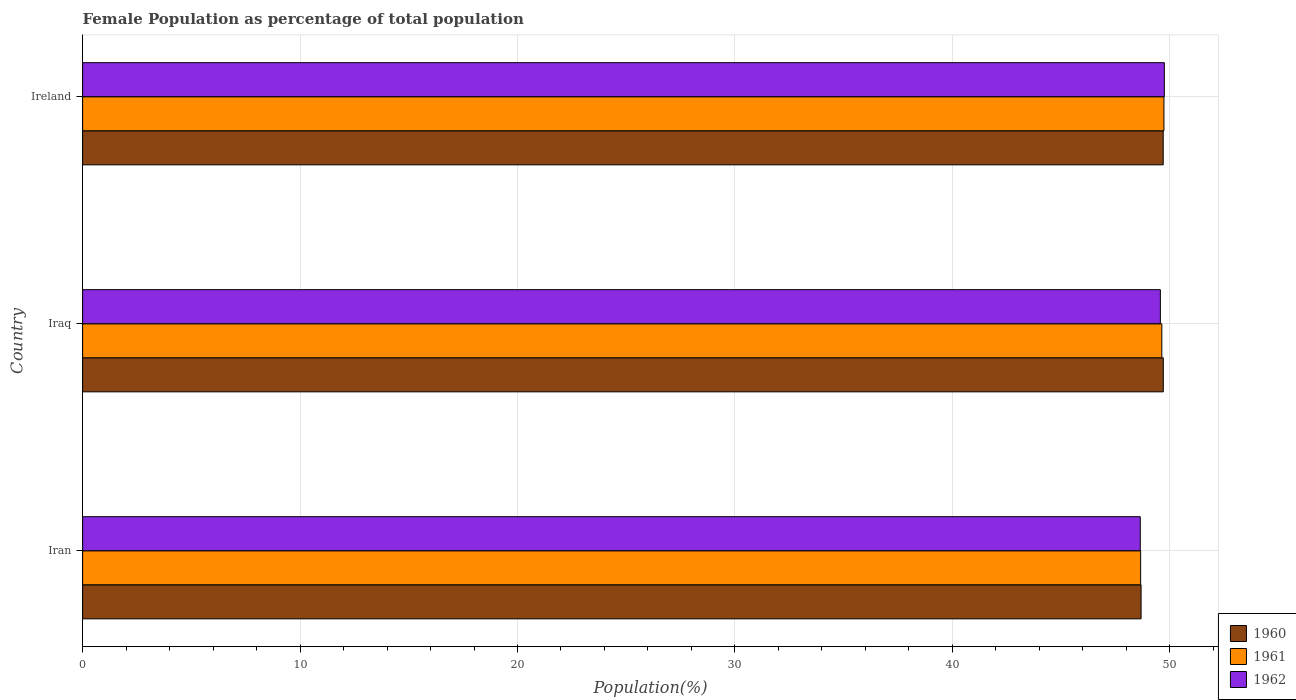How many different coloured bars are there?
Give a very brief answer. 3. Are the number of bars per tick equal to the number of legend labels?
Your answer should be very brief. Yes. Are the number of bars on each tick of the Y-axis equal?
Offer a terse response. Yes. How many bars are there on the 2nd tick from the top?
Give a very brief answer. 3. How many bars are there on the 3rd tick from the bottom?
Provide a succinct answer. 3. What is the label of the 1st group of bars from the top?
Provide a short and direct response. Ireland. What is the female population in in 1960 in Iran?
Make the answer very short. 48.68. Across all countries, what is the maximum female population in in 1961?
Your response must be concise. 49.73. Across all countries, what is the minimum female population in in 1961?
Make the answer very short. 48.66. In which country was the female population in in 1962 maximum?
Offer a terse response. Ireland. In which country was the female population in in 1960 minimum?
Give a very brief answer. Iran. What is the total female population in in 1962 in the graph?
Provide a succinct answer. 147.96. What is the difference between the female population in in 1960 in Iraq and that in Ireland?
Keep it short and to the point. 0. What is the difference between the female population in in 1960 in Iraq and the female population in in 1961 in Iran?
Your response must be concise. 1.04. What is the average female population in in 1962 per country?
Keep it short and to the point. 49.32. What is the difference between the female population in in 1961 and female population in in 1962 in Iraq?
Offer a very short reply. 0.07. What is the ratio of the female population in in 1961 in Iraq to that in Ireland?
Keep it short and to the point. 1. What is the difference between the highest and the second highest female population in in 1961?
Give a very brief answer. 0.1. What is the difference between the highest and the lowest female population in in 1962?
Give a very brief answer. 1.11. In how many countries, is the female population in in 1960 greater than the average female population in in 1960 taken over all countries?
Keep it short and to the point. 2. What does the 2nd bar from the bottom in Iraq represents?
Provide a short and direct response. 1961. Are all the bars in the graph horizontal?
Keep it short and to the point. Yes. What is the difference between two consecutive major ticks on the X-axis?
Your answer should be compact. 10. Are the values on the major ticks of X-axis written in scientific E-notation?
Keep it short and to the point. No. Does the graph contain any zero values?
Provide a short and direct response. No. Where does the legend appear in the graph?
Your response must be concise. Bottom right. How many legend labels are there?
Offer a very short reply. 3. What is the title of the graph?
Keep it short and to the point. Female Population as percentage of total population. Does "2004" appear as one of the legend labels in the graph?
Your answer should be very brief. No. What is the label or title of the X-axis?
Your answer should be very brief. Population(%). What is the Population(%) of 1960 in Iran?
Provide a short and direct response. 48.68. What is the Population(%) of 1961 in Iran?
Keep it short and to the point. 48.66. What is the Population(%) in 1962 in Iran?
Keep it short and to the point. 48.64. What is the Population(%) in 1960 in Iraq?
Your answer should be very brief. 49.7. What is the Population(%) in 1961 in Iraq?
Provide a succinct answer. 49.63. What is the Population(%) of 1962 in Iraq?
Ensure brevity in your answer.  49.57. What is the Population(%) of 1960 in Ireland?
Your answer should be compact. 49.7. What is the Population(%) in 1961 in Ireland?
Ensure brevity in your answer.  49.73. What is the Population(%) in 1962 in Ireland?
Offer a terse response. 49.75. Across all countries, what is the maximum Population(%) in 1960?
Your response must be concise. 49.7. Across all countries, what is the maximum Population(%) in 1961?
Your answer should be compact. 49.73. Across all countries, what is the maximum Population(%) of 1962?
Offer a very short reply. 49.75. Across all countries, what is the minimum Population(%) in 1960?
Make the answer very short. 48.68. Across all countries, what is the minimum Population(%) in 1961?
Your answer should be very brief. 48.66. Across all countries, what is the minimum Population(%) in 1962?
Give a very brief answer. 48.64. What is the total Population(%) in 1960 in the graph?
Offer a very short reply. 148.08. What is the total Population(%) in 1961 in the graph?
Your answer should be compact. 148.03. What is the total Population(%) of 1962 in the graph?
Keep it short and to the point. 147.96. What is the difference between the Population(%) in 1960 in Iran and that in Iraq?
Your answer should be compact. -1.02. What is the difference between the Population(%) of 1961 in Iran and that in Iraq?
Offer a terse response. -0.97. What is the difference between the Population(%) of 1962 in Iran and that in Iraq?
Give a very brief answer. -0.92. What is the difference between the Population(%) in 1960 in Iran and that in Ireland?
Provide a short and direct response. -1.02. What is the difference between the Population(%) of 1961 in Iran and that in Ireland?
Your response must be concise. -1.07. What is the difference between the Population(%) of 1962 in Iran and that in Ireland?
Keep it short and to the point. -1.11. What is the difference between the Population(%) of 1960 in Iraq and that in Ireland?
Offer a terse response. 0. What is the difference between the Population(%) of 1961 in Iraq and that in Ireland?
Give a very brief answer. -0.1. What is the difference between the Population(%) in 1962 in Iraq and that in Ireland?
Ensure brevity in your answer.  -0.18. What is the difference between the Population(%) in 1960 in Iran and the Population(%) in 1961 in Iraq?
Your answer should be compact. -0.95. What is the difference between the Population(%) of 1960 in Iran and the Population(%) of 1962 in Iraq?
Provide a short and direct response. -0.89. What is the difference between the Population(%) of 1961 in Iran and the Population(%) of 1962 in Iraq?
Offer a terse response. -0.91. What is the difference between the Population(%) of 1960 in Iran and the Population(%) of 1961 in Ireland?
Your answer should be compact. -1.05. What is the difference between the Population(%) of 1960 in Iran and the Population(%) of 1962 in Ireland?
Ensure brevity in your answer.  -1.07. What is the difference between the Population(%) of 1961 in Iran and the Population(%) of 1962 in Ireland?
Make the answer very short. -1.09. What is the difference between the Population(%) of 1960 in Iraq and the Population(%) of 1961 in Ireland?
Make the answer very short. -0.03. What is the difference between the Population(%) of 1960 in Iraq and the Population(%) of 1962 in Ireland?
Your answer should be compact. -0.05. What is the difference between the Population(%) in 1961 in Iraq and the Population(%) in 1962 in Ireland?
Keep it short and to the point. -0.12. What is the average Population(%) in 1960 per country?
Give a very brief answer. 49.36. What is the average Population(%) in 1961 per country?
Offer a very short reply. 49.34. What is the average Population(%) of 1962 per country?
Your response must be concise. 49.32. What is the difference between the Population(%) of 1960 and Population(%) of 1962 in Iran?
Ensure brevity in your answer.  0.04. What is the difference between the Population(%) in 1961 and Population(%) in 1962 in Iran?
Offer a terse response. 0.02. What is the difference between the Population(%) in 1960 and Population(%) in 1961 in Iraq?
Offer a terse response. 0.07. What is the difference between the Population(%) in 1960 and Population(%) in 1962 in Iraq?
Ensure brevity in your answer.  0.13. What is the difference between the Population(%) of 1961 and Population(%) of 1962 in Iraq?
Your answer should be compact. 0.07. What is the difference between the Population(%) of 1960 and Population(%) of 1961 in Ireland?
Offer a very short reply. -0.03. What is the difference between the Population(%) in 1960 and Population(%) in 1962 in Ireland?
Offer a terse response. -0.05. What is the difference between the Population(%) of 1961 and Population(%) of 1962 in Ireland?
Provide a short and direct response. -0.02. What is the ratio of the Population(%) of 1960 in Iran to that in Iraq?
Give a very brief answer. 0.98. What is the ratio of the Population(%) of 1961 in Iran to that in Iraq?
Your answer should be very brief. 0.98. What is the ratio of the Population(%) of 1962 in Iran to that in Iraq?
Make the answer very short. 0.98. What is the ratio of the Population(%) in 1960 in Iran to that in Ireland?
Your answer should be compact. 0.98. What is the ratio of the Population(%) of 1961 in Iran to that in Ireland?
Your answer should be compact. 0.98. What is the ratio of the Population(%) of 1962 in Iran to that in Ireland?
Provide a short and direct response. 0.98. What is the ratio of the Population(%) in 1960 in Iraq to that in Ireland?
Offer a terse response. 1. What is the ratio of the Population(%) of 1962 in Iraq to that in Ireland?
Provide a short and direct response. 1. What is the difference between the highest and the second highest Population(%) of 1960?
Keep it short and to the point. 0. What is the difference between the highest and the second highest Population(%) in 1961?
Ensure brevity in your answer.  0.1. What is the difference between the highest and the second highest Population(%) in 1962?
Keep it short and to the point. 0.18. What is the difference between the highest and the lowest Population(%) in 1960?
Give a very brief answer. 1.02. What is the difference between the highest and the lowest Population(%) in 1961?
Ensure brevity in your answer.  1.07. What is the difference between the highest and the lowest Population(%) in 1962?
Make the answer very short. 1.11. 